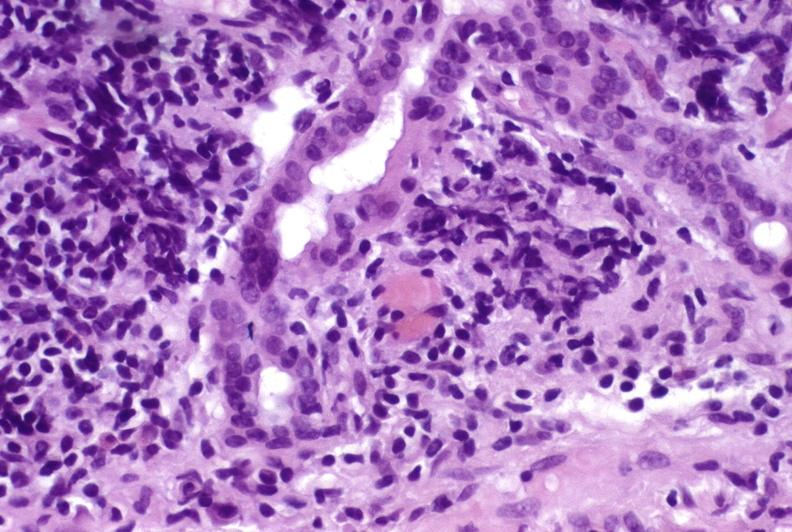s this image shows of smooth muscle cell with lipid in sarcoplasm and lipid present?
Answer the question using a single word or phrase. No 